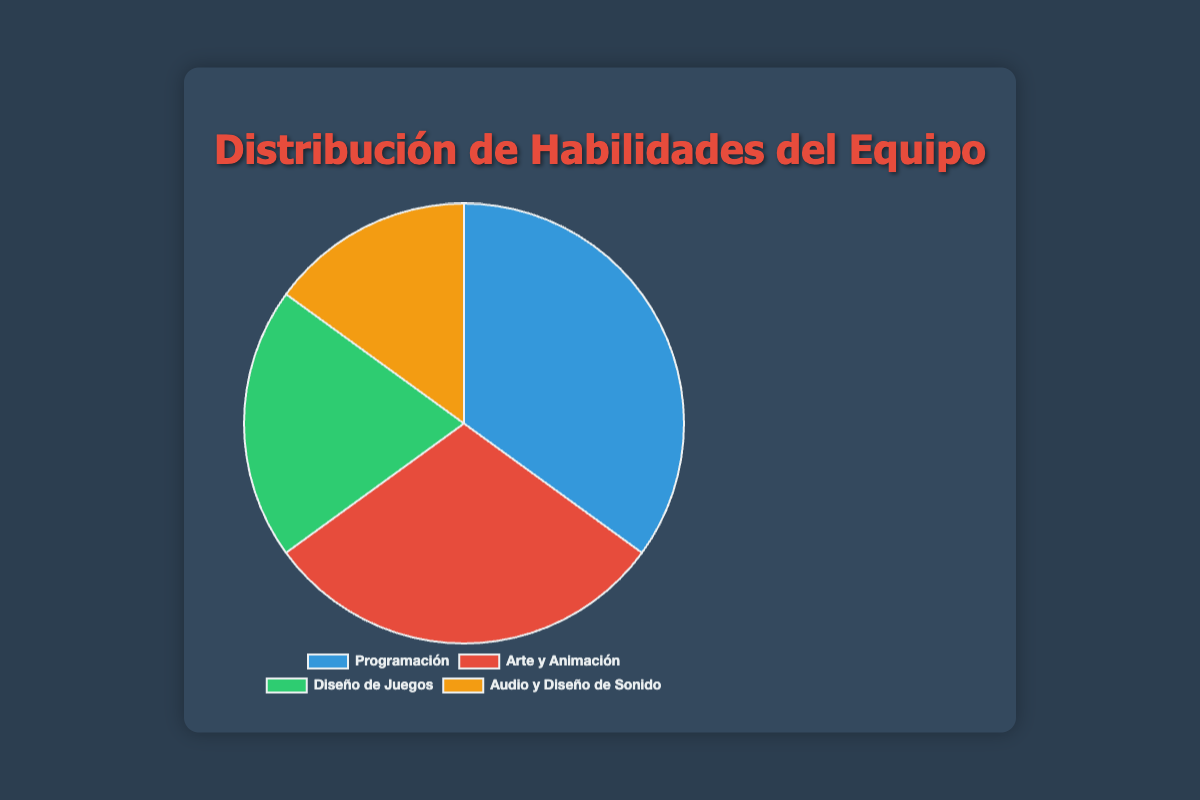1. ¿Cuál es la habilidad con el porcentaje más alto? El gráfico de la torta muestra que "Programación" tiene el segmento más grande.
Answer: Programación 2. ¿Qué habilidades representan juntas el 50% del equipo? Sumamos los porcentajes de "Arte y Animación" (30%) y "Programación" (35%). Total = 30% + 35% = 65%. Luego, sumamos "Game Design" (20%) y "Audio y Diseño de Sonido" (15%). Total = 20% + 15% = 35%. La combinación más cercana al 50% es "Arte y Animación" y "Game Design".
Answer: Arte y Animación y Game Design 3. ¿Cuánto mayor es el porcentaje de "Programación" en comparación con "Game Design"? Restamos el porcentaje de "Game Design" (20%) del de "Programación" (35%). Diferencia = 35% - 20% = 15%.
Answer: 15% 4. ¿Qué color representa a "Arte y Animación"? Según la configuración del gráfico, "Arte y Animación" está representado por el color rojo.
Answer: Rojo 5. ¿Qué habilidades ocupan menos del 25% cada una? Observamos que "Game Design" con 20% y "Audio y Diseño de Sonido" con 15% son las habilidades que cumplen este criterio.
Answer: Game Design y Audio y Diseño de Sonido 6. ¿Cuál es el porcentaje total de habilidades no relacionadas con la programación? Sumamos los porcentajes de "Arte y Animación" (30%), "Game Design" (20%) y "Audio y Diseño de Sonido" (15%). Total = 30% + 20% + 15% = 65%.
Answer: 65% 7. ¿Qué habilidad se encuentra justo por detrás de "Programación" en términos de porcentaje? La segunda sección más grande del gráfico después de "Programación" (35%) es "Arte y Animación" (30%).
Answer: Arte y Animación 8. ¿Qué habilidad tiene el menor porcentaje y cuánto es? El segmento más pequeño corresponde a "Audio y Diseño de Sonido" con un 15%.
Answer: Audio y Diseño de Sonido, 15% 9. ¿Cómo se comparan en conjunto "Arte y Animación" y "Audio y Diseño de Sonido" frente a "Programación"? Sumamos los porcentajes de "Arte y Animación" (30%) y "Audio y Diseño de Sonido" (15%). Total = 30% + 15% = 45%. "Programación" tiene 35%, por lo tanto, 45% es mayor que 35%.
Answer: 45% es mayor que 35% 10. ¿Qué porcentaje sería necesario agregar a "Audio y Diseño de Sonido" para igualar a "Arte y Animación"? "Arte y Animación" tiene 30% y "Audio y Diseño de Sonido" tiene 15%. Restamos estos valores para encontrar la diferencia. Diferencia = 30% - 15% = 15%.
Answer: 15% 